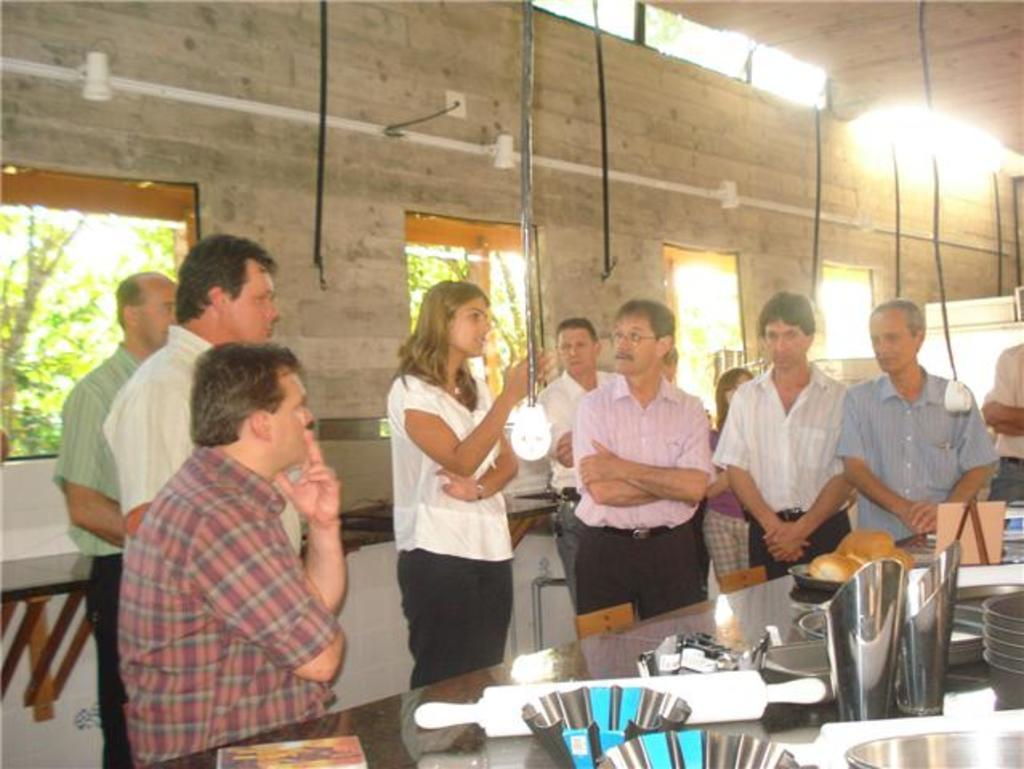How many people are in the image? There is a group of people in the image. What is the position of one person in the group? One person is seated. What is the woman in the image doing? A woman is speaking. What is present on the table in the image? There is a table in the image, and on it, there are jars and bowls. What type of advertisement can be seen on the roof in the image? There is no advertisement or roof present in the image. 